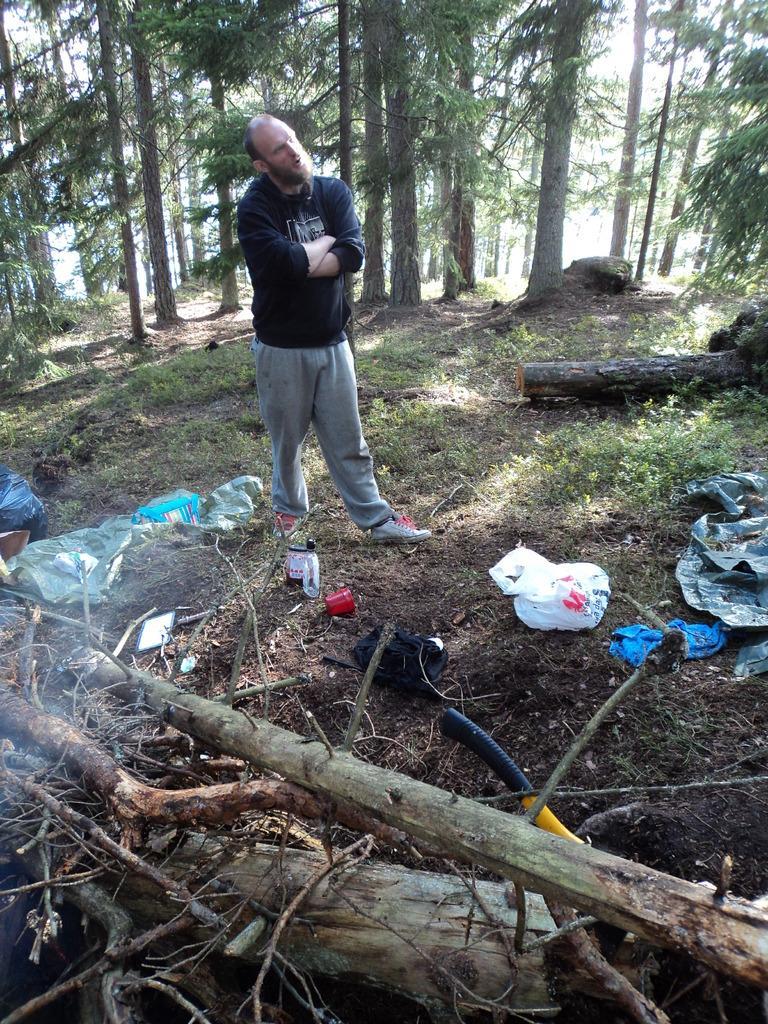How would you summarize this image in a sentence or two? In this picture there is a man standing and we can see wooden objects, cover, cloth, bag and few objects. We can see grass and trees. In the background of the image we can see the sky. 